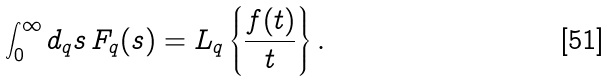Convert formula to latex. <formula><loc_0><loc_0><loc_500><loc_500>\int _ { 0 } ^ { \infty } d _ { q } s \, F _ { q } ( s ) = L _ { q } \left \{ \frac { f ( t ) } { t } \right \} .</formula> 